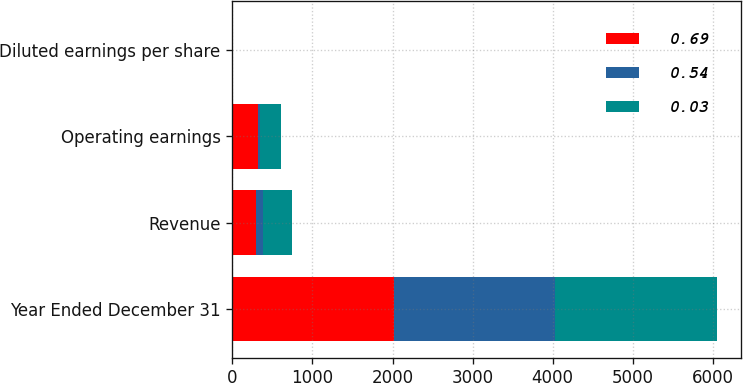Convert chart. <chart><loc_0><loc_0><loc_500><loc_500><stacked_bar_chart><ecel><fcel>Year Ended December 31<fcel>Revenue<fcel>Operating earnings<fcel>Diluted earnings per share<nl><fcel>0.69<fcel>2017<fcel>292<fcel>323<fcel>0.69<nl><fcel>0.54<fcel>2016<fcel>95<fcel>16<fcel>0.03<nl><fcel>0.03<fcel>2015<fcel>356<fcel>271<fcel>0.54<nl></chart> 